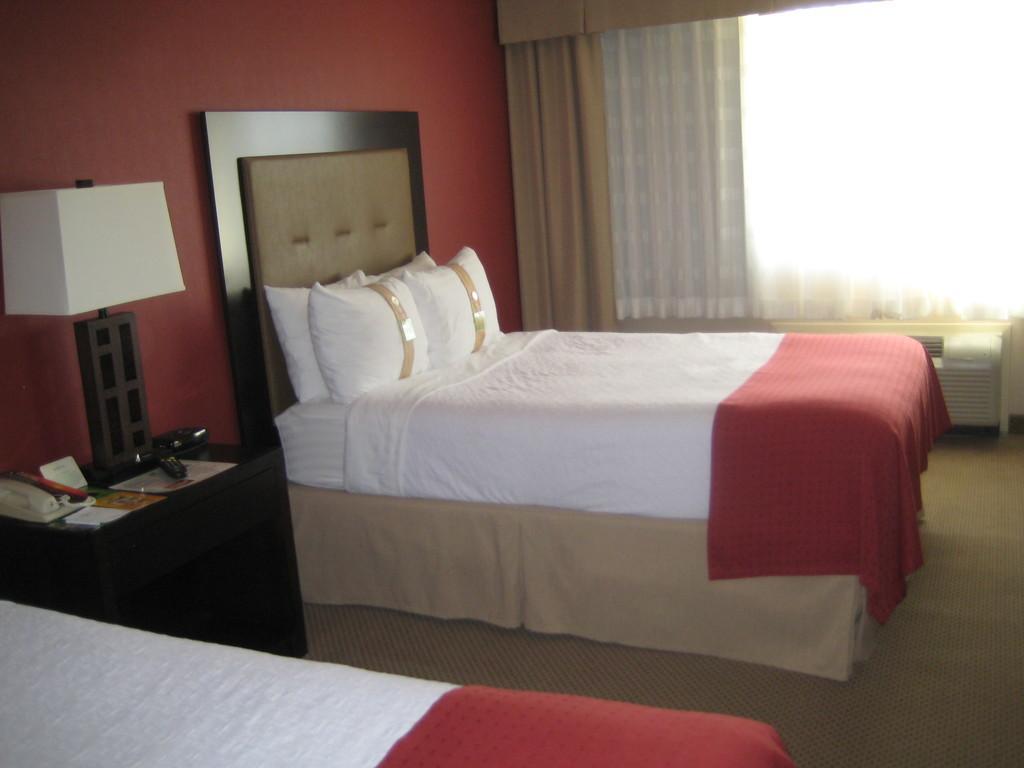How would you summarize this image in a sentence or two? In this image ,in the middle there is a bed. To the right there is a window attached with a curtain. In the back of the bed there is a wall and side by the bed there is a table and lamp. 